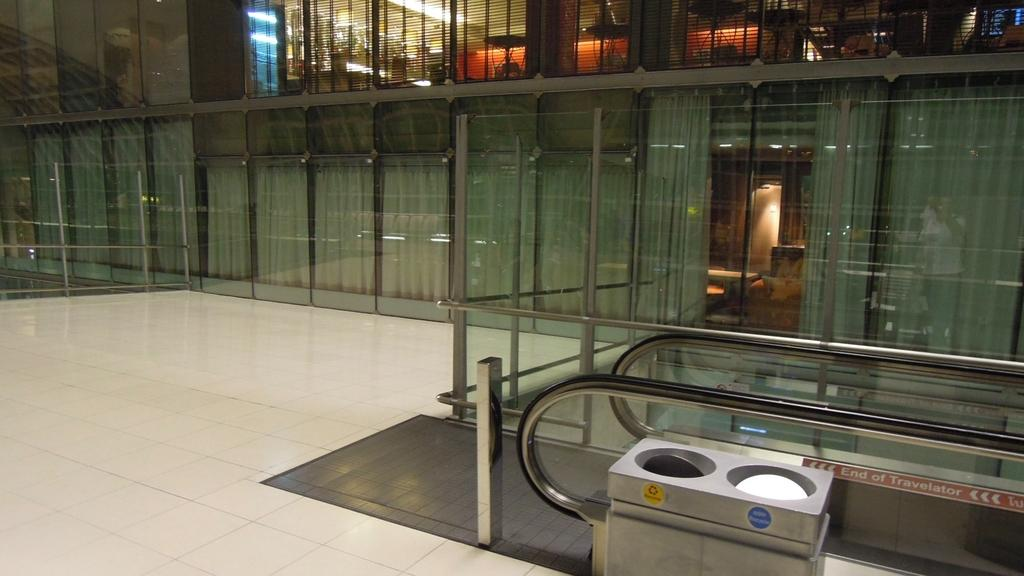<image>
Provide a brief description of the given image. The trash bin with the non recycle sticker sits in front of the Travelator. 